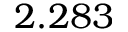<formula> <loc_0><loc_0><loc_500><loc_500>2 . 2 8 3</formula> 